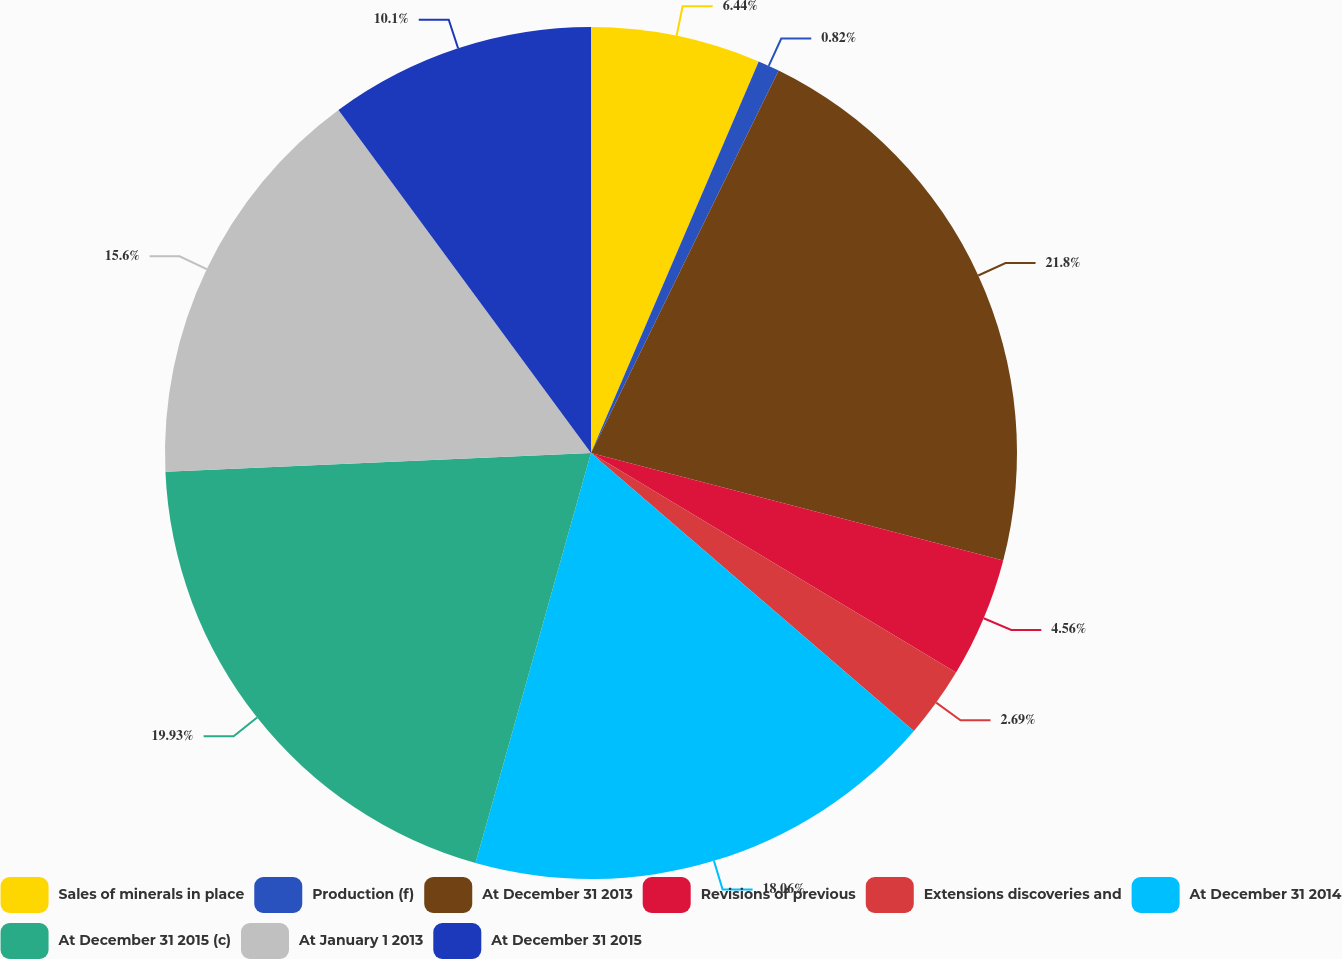Convert chart to OTSL. <chart><loc_0><loc_0><loc_500><loc_500><pie_chart><fcel>Sales of minerals in place<fcel>Production (f)<fcel>At December 31 2013<fcel>Revisions of previous<fcel>Extensions discoveries and<fcel>At December 31 2014<fcel>At December 31 2015 (c)<fcel>At January 1 2013<fcel>At December 31 2015<nl><fcel>6.44%<fcel>0.82%<fcel>21.8%<fcel>4.56%<fcel>2.69%<fcel>18.06%<fcel>19.93%<fcel>15.6%<fcel>10.1%<nl></chart> 